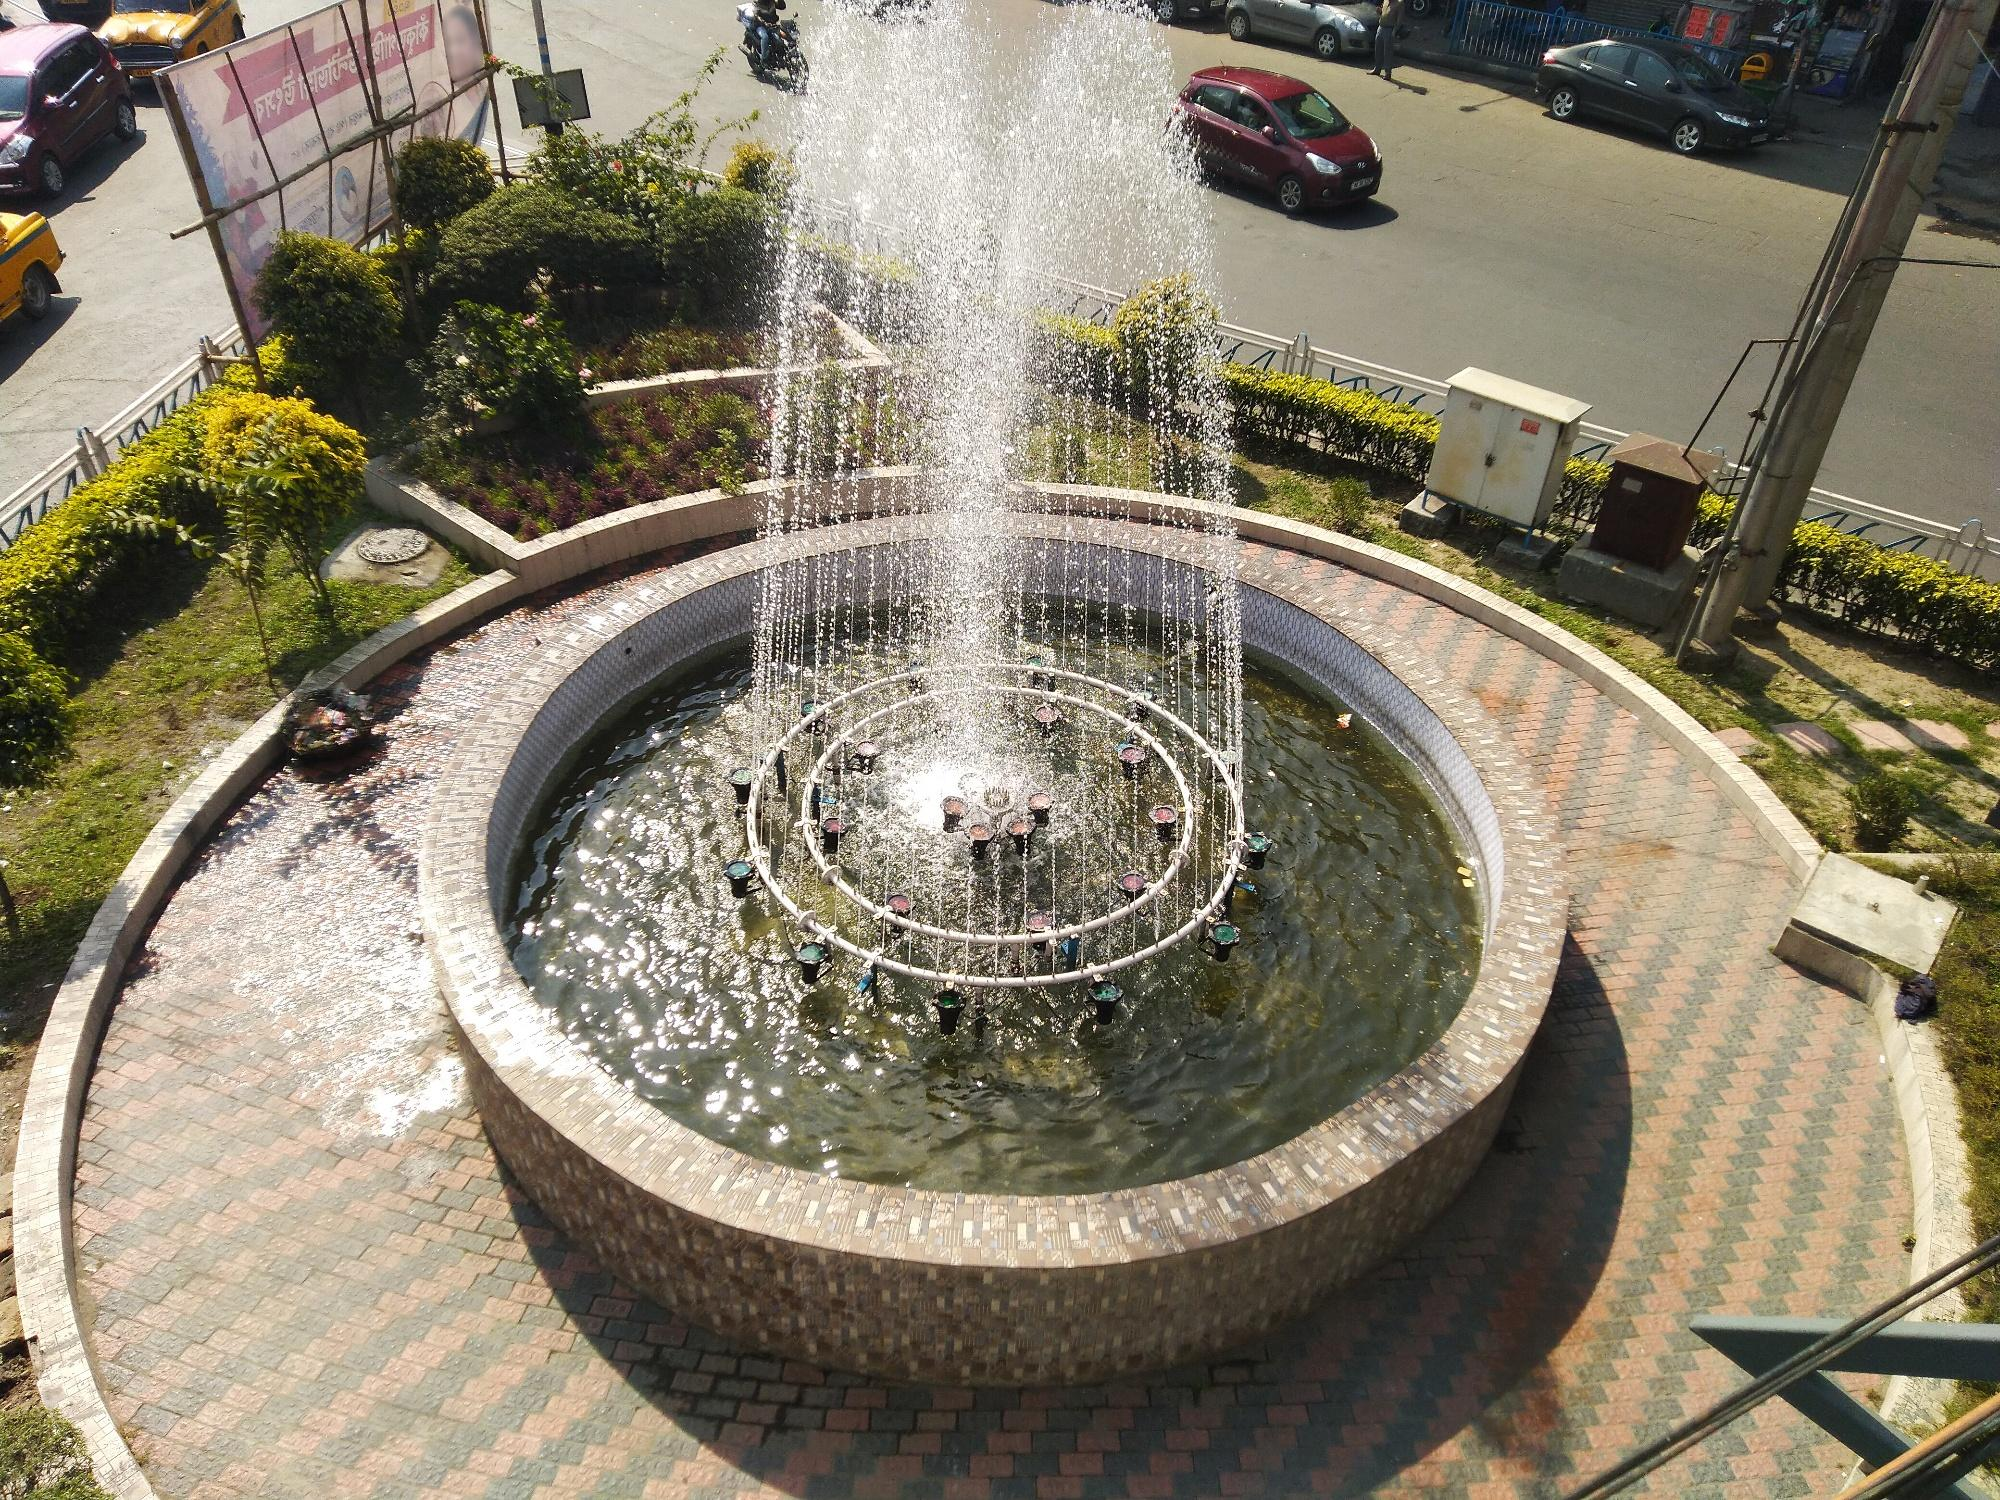Explain in detail how this fountain might have been constructed. Constructing this fountain would start with carefully planning the design, accounting for the aesthetic integration into the roundabout. The foundation would be excavated and laid with reinforced concrete to ensure stability. Bricklayers would then construct the circular base and the inner pool using high-quality bricks, ensuring durability.

Waterproofing solutions would be applied to the pool's interior to prevent leaks. Next, the hydraulic system would be installed, including pumps and pipes to ensure water circulation. Fixtures for the water jets would be strategically placed at the center to create the upward spray effect.

Surrounding the fountain, a brick-paved walkway would be constructed, and landscapers would design and plant the greenery, choosing plants that thrive in the local climate. Lighting and other decorative elements might be installed last, adding the final touches to ensure the fountain not only functions well but also enhances the area's visual appeal. 